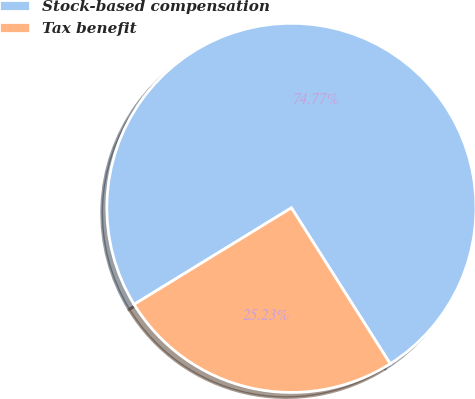<chart> <loc_0><loc_0><loc_500><loc_500><pie_chart><fcel>Stock-based compensation<fcel>Tax benefit<nl><fcel>74.77%<fcel>25.23%<nl></chart> 